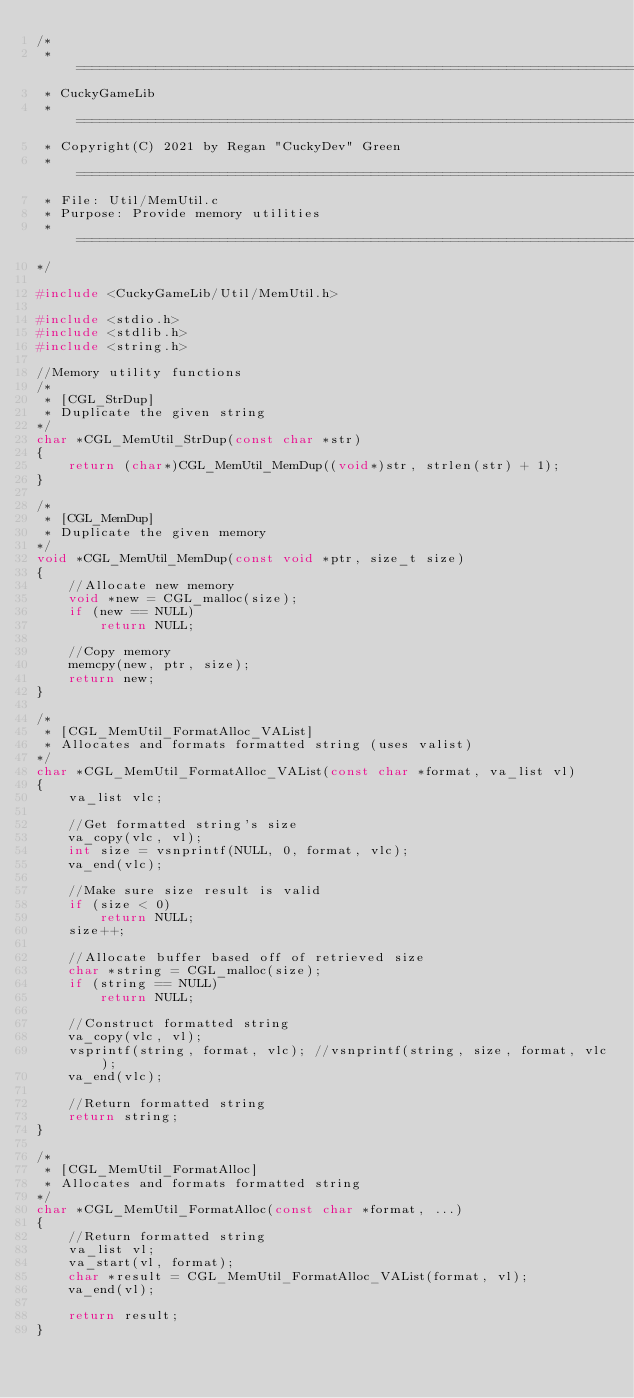<code> <loc_0><loc_0><loc_500><loc_500><_C_>/*
 * =============================================================================
 * CuckyGameLib
 * =============================================================================
 * Copyright(C) 2021 by Regan "CuckyDev" Green
 * =============================================================================
 * File: Util/MemUtil.c
 * Purpose: Provide memory utilities
 * =============================================================================
*/

#include <CuckyGameLib/Util/MemUtil.h>

#include <stdio.h>
#include <stdlib.h>
#include <string.h>

//Memory utility functions
/*
 * [CGL_StrDup]
 * Duplicate the given string
*/
char *CGL_MemUtil_StrDup(const char *str)
{
	return (char*)CGL_MemUtil_MemDup((void*)str, strlen(str) + 1);
}

/*
 * [CGL_MemDup]
 * Duplicate the given memory
*/
void *CGL_MemUtil_MemDup(const void *ptr, size_t size)
{
	//Allocate new memory
	void *new = CGL_malloc(size);
	if (new == NULL)
		return NULL;
	
	//Copy memory
	memcpy(new, ptr, size);
	return new;
}

/*
 * [CGL_MemUtil_FormatAlloc_VAList]
 * Allocates and formats formatted string (uses valist)
*/
char *CGL_MemUtil_FormatAlloc_VAList(const char *format, va_list vl)
{
	va_list vlc;
	
	//Get formatted string's size
	va_copy(vlc, vl);
	int size = vsnprintf(NULL, 0, format, vlc);
	va_end(vlc);
	
	//Make sure size result is valid
	if (size < 0)
		return NULL;
	size++;
	
	//Allocate buffer based off of retrieved size
	char *string = CGL_malloc(size);
	if (string == NULL)
		return NULL;
	
	//Construct formatted string
	va_copy(vlc, vl);
	vsprintf(string, format, vlc); //vsnprintf(string, size, format, vlc);
	va_end(vlc);
	
	//Return formatted string
	return string;
}

/*
 * [CGL_MemUtil_FormatAlloc]
 * Allocates and formats formatted string
*/
char *CGL_MemUtil_FormatAlloc(const char *format, ...)
{
	//Return formatted string
	va_list vl;
	va_start(vl, format);
	char *result = CGL_MemUtil_FormatAlloc_VAList(format, vl);
	va_end(vl);
	
	return result;
}
</code> 